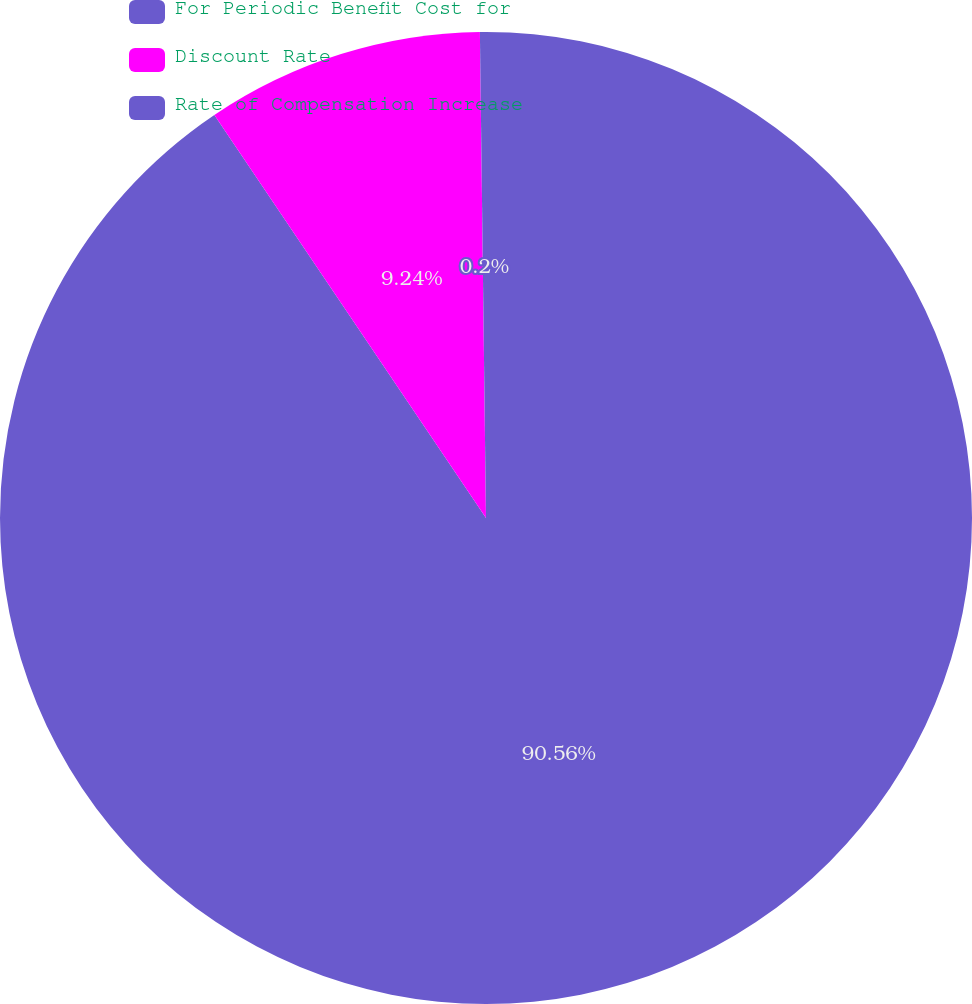Convert chart to OTSL. <chart><loc_0><loc_0><loc_500><loc_500><pie_chart><fcel>For Periodic Benefit Cost for<fcel>Discount Rate<fcel>Rate of Compensation Increase<nl><fcel>90.56%<fcel>9.24%<fcel>0.2%<nl></chart> 